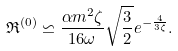<formula> <loc_0><loc_0><loc_500><loc_500>\mathfrak { R } ^ { ( 0 ) } \backsimeq \frac { \alpha m ^ { 2 } \zeta } { 1 6 \omega } \sqrt { \frac { 3 } { 2 } } e ^ { - \frac { 4 } { 3 \zeta } } .</formula> 